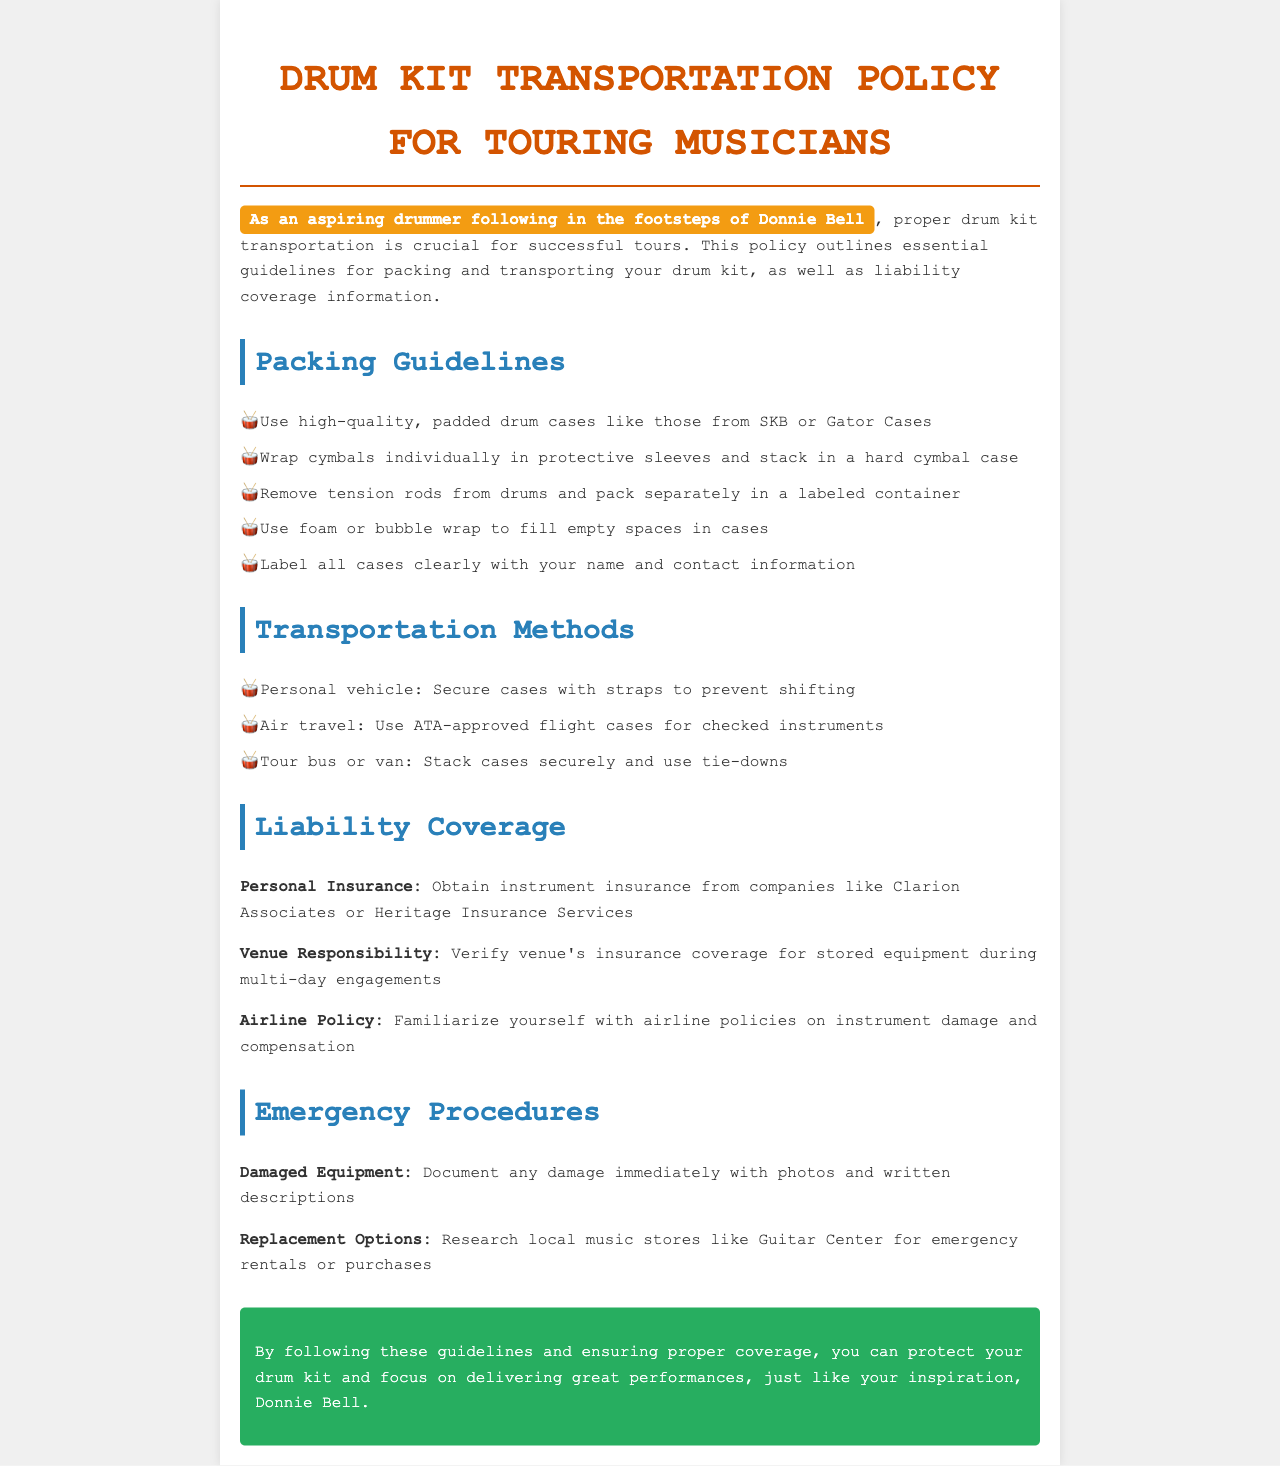What is the title of the document? The title of the document is specified in the header section: "Drum Kit Transportation Policy for Touring Musicians."
Answer: Drum Kit Transportation Policy for Touring Musicians What should you wrap cymbals in? The document states that cymbals should be wrapped individually in protective sleeves.
Answer: Protective sleeves What type of cases should be used for air travel? The guideline indicates that you should use ATA-approved flight cases for checked instruments.
Answer: ATA-approved flight cases What should be done if equipment is damaged? The policy suggests documenting any damage immediately with photos and written descriptions.
Answer: Document with photos and written descriptions Which companies are recommended for personal insurance? The document mentions two companies: Clarion Associates and Heritage Insurance Services.
Answer: Clarion Associates or Heritage Insurance Services What should you use to fill empty spaces in cases? According to the packing guidelines, foam or bubble wrap should be used to fill empty spaces.
Answer: Foam or bubble wrap What is one type of transportation method listed? The document lists several methods, one of which is personal vehicle.
Answer: Personal vehicle What information should be labeled on all cases? It is advised that all cases should be labeled clearly with your name and contact information.
Answer: Your name and contact information 